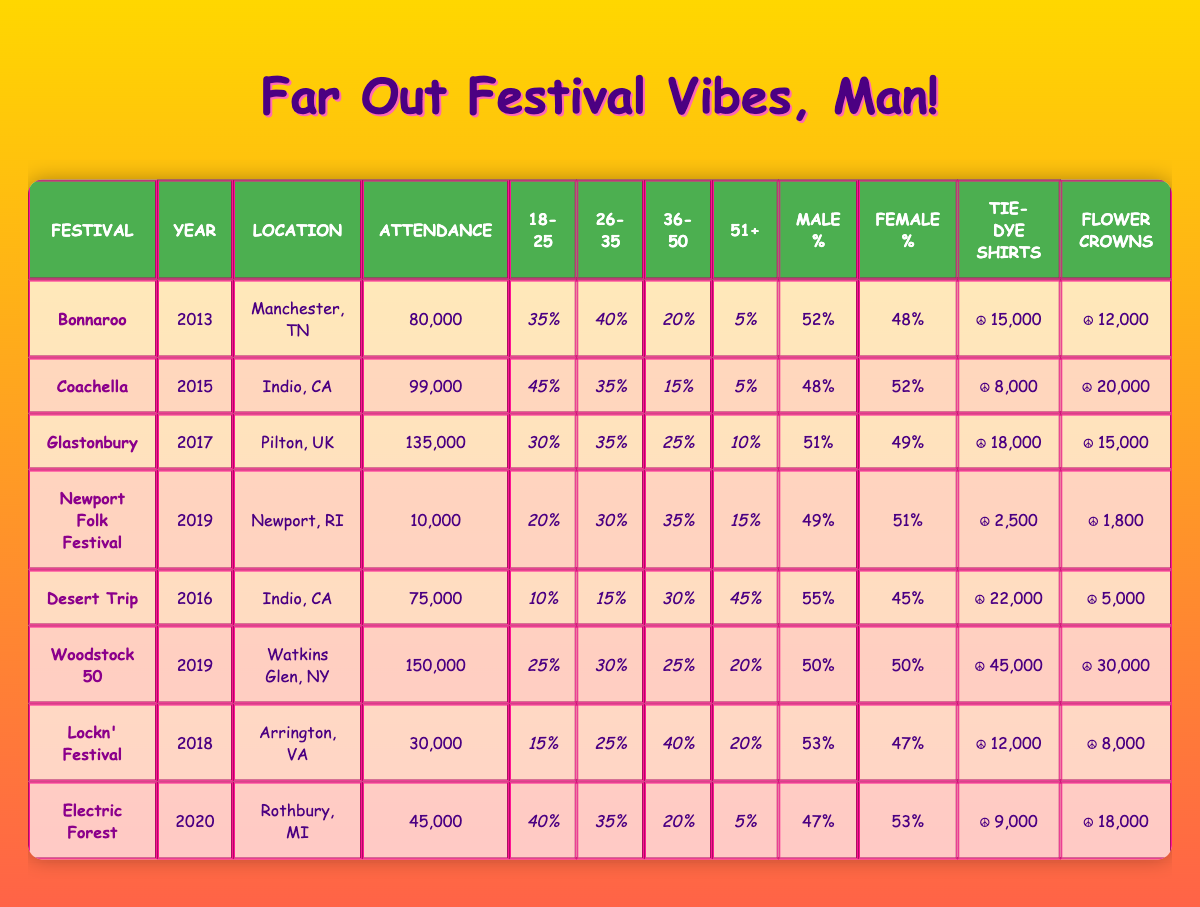What's the total attendance at Bonnaroo in 2013? The attendance for Bonnaroo in 2013 can be found in the table under the "Attendance" column. It shows a value of 80,000.
Answer: 80,000 Which festival had the highest attendance in the last decade? Looking through the "Attendance" column, the maximum number is 150,000, which belongs to Woodstock 50 in 2019.
Answer: Woodstock 50 What percentage of attendees at Electric Forest were aged 18-25? In the table, under Electric Forest, the percentage for the age group 18-25 is listed as 40%.
Answer: 40% How many more tie-dye shirts were worn at Woodstock 50 compared to Newport Folk Festival? According to the table, Woodstock 50 had 45,000 tie-dye shirts and Newport Folk Festival had 2,500. The difference is 45,000 - 2,500 = 42,500.
Answer: 42,500 What was the combined percentage of attendees aged 36-50 across all festivals listed? By summing the "36-50" percentages from each festival: 20 + 15 + 25 + 35 + 30 + 25 + 40 + 20 = 200. This total shows that the combined percentage is 200%.
Answer: 200% Did more than half of the attendees at Desert Trip identify as male? Referencing the "Male %" column for Desert Trip, the value shows 55%. Since 55% is greater than 50%, the answer is yes.
Answer: Yes Which festival had a higher female attendance percentage: Coachella or Glastonbury? Coachella has a female percentage of 52%, while Glastonbury's percentage is 49%. Comparing these numbers, Coachella has the higher percentage.
Answer: Coachella What is the average attendance of festivals held in Indio, CA? There are two festivals in Indio, CA: Coachella (99,000) and Desert Trip (75,000). The average is (99,000 + 75,000) / 2 = 174,000 / 2 = 87,000.
Answer: 87,000 For which festival was the population of attendees aged 51 and older the highest, and what was that percentage? By checking the "51+" column, Desert Trip has 45%, which is the highest percentage for attendees aged 51 and older.
Answer: Desert Trip, 45% 